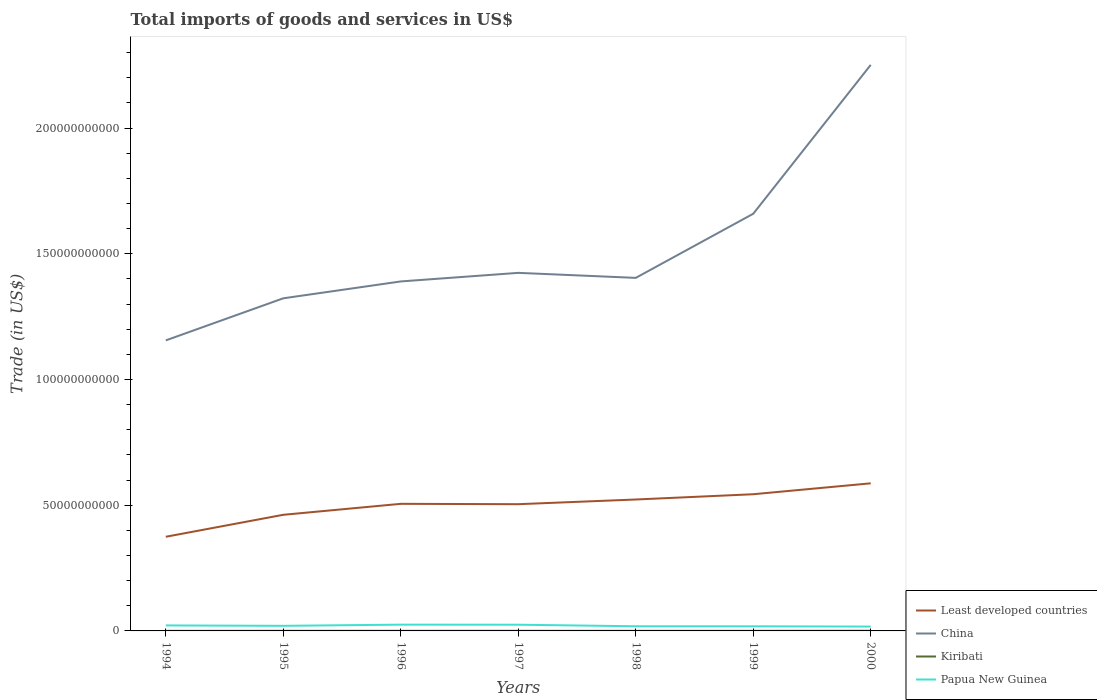How many different coloured lines are there?
Keep it short and to the point. 4. Does the line corresponding to Least developed countries intersect with the line corresponding to China?
Your answer should be very brief. No. Across all years, what is the maximum total imports of goods and services in Least developed countries?
Your answer should be compact. 3.75e+1. In which year was the total imports of goods and services in Kiribati maximum?
Offer a terse response. 1994. What is the total total imports of goods and services in Least developed countries in the graph?
Your answer should be compact. -4.22e+09. What is the difference between the highest and the second highest total imports of goods and services in Papua New Guinea?
Your response must be concise. 7.61e+08. Are the values on the major ticks of Y-axis written in scientific E-notation?
Make the answer very short. No. Does the graph contain any zero values?
Offer a very short reply. No. Does the graph contain grids?
Offer a terse response. No. Where does the legend appear in the graph?
Give a very brief answer. Bottom right. How many legend labels are there?
Offer a very short reply. 4. How are the legend labels stacked?
Provide a short and direct response. Vertical. What is the title of the graph?
Give a very brief answer. Total imports of goods and services in US$. What is the label or title of the X-axis?
Make the answer very short. Years. What is the label or title of the Y-axis?
Your response must be concise. Trade (in US$). What is the Trade (in US$) of Least developed countries in 1994?
Your answer should be compact. 3.75e+1. What is the Trade (in US$) of China in 1994?
Provide a succinct answer. 1.16e+11. What is the Trade (in US$) in Kiribati in 1994?
Provide a succinct answer. 3.38e+07. What is the Trade (in US$) of Papua New Guinea in 1994?
Ensure brevity in your answer.  2.19e+09. What is the Trade (in US$) in Least developed countries in 1995?
Provide a succinct answer. 4.62e+1. What is the Trade (in US$) of China in 1995?
Your answer should be very brief. 1.32e+11. What is the Trade (in US$) of Kiribati in 1995?
Your answer should be compact. 4.14e+07. What is the Trade (in US$) in Papua New Guinea in 1995?
Offer a very short reply. 2.03e+09. What is the Trade (in US$) of Least developed countries in 1996?
Provide a succinct answer. 5.06e+1. What is the Trade (in US$) in China in 1996?
Offer a very short reply. 1.39e+11. What is the Trade (in US$) in Kiribati in 1996?
Keep it short and to the point. 4.62e+07. What is the Trade (in US$) of Papua New Guinea in 1996?
Keep it short and to the point. 2.50e+09. What is the Trade (in US$) in Least developed countries in 1997?
Your response must be concise. 5.04e+1. What is the Trade (in US$) of China in 1997?
Offer a very short reply. 1.42e+11. What is the Trade (in US$) in Kiribati in 1997?
Make the answer very short. 4.29e+07. What is the Trade (in US$) of Papua New Guinea in 1997?
Your answer should be very brief. 2.47e+09. What is the Trade (in US$) in Least developed countries in 1998?
Make the answer very short. 5.23e+1. What is the Trade (in US$) in China in 1998?
Offer a very short reply. 1.40e+11. What is the Trade (in US$) in Kiribati in 1998?
Give a very brief answer. 3.48e+07. What is the Trade (in US$) of Papua New Guinea in 1998?
Make the answer very short. 1.85e+09. What is the Trade (in US$) in Least developed countries in 1999?
Provide a short and direct response. 5.44e+1. What is the Trade (in US$) in China in 1999?
Offer a very short reply. 1.66e+11. What is the Trade (in US$) in Kiribati in 1999?
Keep it short and to the point. 3.72e+07. What is the Trade (in US$) in Papua New Guinea in 1999?
Your answer should be very brief. 1.84e+09. What is the Trade (in US$) in Least developed countries in 2000?
Your answer should be compact. 5.87e+1. What is the Trade (in US$) in China in 2000?
Your answer should be compact. 2.25e+11. What is the Trade (in US$) of Kiribati in 2000?
Your answer should be compact. 6.25e+07. What is the Trade (in US$) in Papua New Guinea in 2000?
Keep it short and to the point. 1.73e+09. Across all years, what is the maximum Trade (in US$) of Least developed countries?
Give a very brief answer. 5.87e+1. Across all years, what is the maximum Trade (in US$) in China?
Offer a terse response. 2.25e+11. Across all years, what is the maximum Trade (in US$) in Kiribati?
Make the answer very short. 6.25e+07. Across all years, what is the maximum Trade (in US$) of Papua New Guinea?
Offer a terse response. 2.50e+09. Across all years, what is the minimum Trade (in US$) in Least developed countries?
Offer a very short reply. 3.75e+1. Across all years, what is the minimum Trade (in US$) of China?
Keep it short and to the point. 1.16e+11. Across all years, what is the minimum Trade (in US$) of Kiribati?
Your response must be concise. 3.38e+07. Across all years, what is the minimum Trade (in US$) of Papua New Guinea?
Offer a terse response. 1.73e+09. What is the total Trade (in US$) in Least developed countries in the graph?
Make the answer very short. 3.50e+11. What is the total Trade (in US$) of China in the graph?
Your answer should be very brief. 1.06e+12. What is the total Trade (in US$) in Kiribati in the graph?
Offer a terse response. 2.99e+08. What is the total Trade (in US$) in Papua New Guinea in the graph?
Provide a short and direct response. 1.46e+1. What is the difference between the Trade (in US$) of Least developed countries in 1994 and that in 1995?
Keep it short and to the point. -8.74e+09. What is the difference between the Trade (in US$) of China in 1994 and that in 1995?
Offer a very short reply. -1.67e+1. What is the difference between the Trade (in US$) of Kiribati in 1994 and that in 1995?
Provide a succinct answer. -7.69e+06. What is the difference between the Trade (in US$) of Papua New Guinea in 1994 and that in 1995?
Make the answer very short. 1.62e+08. What is the difference between the Trade (in US$) in Least developed countries in 1994 and that in 1996?
Give a very brief answer. -1.31e+1. What is the difference between the Trade (in US$) of China in 1994 and that in 1996?
Ensure brevity in your answer.  -2.34e+1. What is the difference between the Trade (in US$) in Kiribati in 1994 and that in 1996?
Your answer should be compact. -1.25e+07. What is the difference between the Trade (in US$) in Papua New Guinea in 1994 and that in 1996?
Offer a very short reply. -3.07e+08. What is the difference between the Trade (in US$) in Least developed countries in 1994 and that in 1997?
Ensure brevity in your answer.  -1.30e+1. What is the difference between the Trade (in US$) of China in 1994 and that in 1997?
Give a very brief answer. -2.69e+1. What is the difference between the Trade (in US$) of Kiribati in 1994 and that in 1997?
Your response must be concise. -9.14e+06. What is the difference between the Trade (in US$) in Papua New Guinea in 1994 and that in 1997?
Provide a succinct answer. -2.82e+08. What is the difference between the Trade (in US$) of Least developed countries in 1994 and that in 1998?
Keep it short and to the point. -1.48e+1. What is the difference between the Trade (in US$) in China in 1994 and that in 1998?
Provide a short and direct response. -2.49e+1. What is the difference between the Trade (in US$) of Kiribati in 1994 and that in 1998?
Provide a succinct answer. -9.97e+05. What is the difference between the Trade (in US$) in Papua New Guinea in 1994 and that in 1998?
Your answer should be very brief. 3.38e+08. What is the difference between the Trade (in US$) of Least developed countries in 1994 and that in 1999?
Ensure brevity in your answer.  -1.69e+1. What is the difference between the Trade (in US$) in China in 1994 and that in 1999?
Ensure brevity in your answer.  -5.04e+1. What is the difference between the Trade (in US$) of Kiribati in 1994 and that in 1999?
Ensure brevity in your answer.  -3.41e+06. What is the difference between the Trade (in US$) of Papua New Guinea in 1994 and that in 1999?
Keep it short and to the point. 3.49e+08. What is the difference between the Trade (in US$) of Least developed countries in 1994 and that in 2000?
Your answer should be very brief. -2.13e+1. What is the difference between the Trade (in US$) in China in 1994 and that in 2000?
Provide a succinct answer. -1.10e+11. What is the difference between the Trade (in US$) of Kiribati in 1994 and that in 2000?
Give a very brief answer. -2.87e+07. What is the difference between the Trade (in US$) in Papua New Guinea in 1994 and that in 2000?
Offer a very short reply. 4.54e+08. What is the difference between the Trade (in US$) of Least developed countries in 1995 and that in 1996?
Ensure brevity in your answer.  -4.36e+09. What is the difference between the Trade (in US$) of China in 1995 and that in 1996?
Your answer should be very brief. -6.71e+09. What is the difference between the Trade (in US$) in Kiribati in 1995 and that in 1996?
Keep it short and to the point. -4.80e+06. What is the difference between the Trade (in US$) in Papua New Guinea in 1995 and that in 1996?
Your answer should be compact. -4.69e+08. What is the difference between the Trade (in US$) of Least developed countries in 1995 and that in 1997?
Your response must be concise. -4.22e+09. What is the difference between the Trade (in US$) in China in 1995 and that in 1997?
Your answer should be compact. -1.01e+1. What is the difference between the Trade (in US$) of Kiribati in 1995 and that in 1997?
Make the answer very short. -1.45e+06. What is the difference between the Trade (in US$) in Papua New Guinea in 1995 and that in 1997?
Provide a succinct answer. -4.45e+08. What is the difference between the Trade (in US$) in Least developed countries in 1995 and that in 1998?
Offer a terse response. -6.08e+09. What is the difference between the Trade (in US$) of China in 1995 and that in 1998?
Keep it short and to the point. -8.13e+09. What is the difference between the Trade (in US$) of Kiribati in 1995 and that in 1998?
Offer a very short reply. 6.69e+06. What is the difference between the Trade (in US$) of Papua New Guinea in 1995 and that in 1998?
Offer a very short reply. 1.76e+08. What is the difference between the Trade (in US$) in Least developed countries in 1995 and that in 1999?
Give a very brief answer. -8.18e+09. What is the difference between the Trade (in US$) in China in 1995 and that in 1999?
Make the answer very short. -3.36e+1. What is the difference between the Trade (in US$) of Kiribati in 1995 and that in 1999?
Provide a succinct answer. 4.28e+06. What is the difference between the Trade (in US$) of Papua New Guinea in 1995 and that in 1999?
Ensure brevity in your answer.  1.87e+08. What is the difference between the Trade (in US$) in Least developed countries in 1995 and that in 2000?
Offer a very short reply. -1.25e+1. What is the difference between the Trade (in US$) in China in 1995 and that in 2000?
Give a very brief answer. -9.28e+1. What is the difference between the Trade (in US$) in Kiribati in 1995 and that in 2000?
Provide a short and direct response. -2.10e+07. What is the difference between the Trade (in US$) of Papua New Guinea in 1995 and that in 2000?
Keep it short and to the point. 2.92e+08. What is the difference between the Trade (in US$) in Least developed countries in 1996 and that in 1997?
Provide a short and direct response. 1.39e+08. What is the difference between the Trade (in US$) in China in 1996 and that in 1997?
Offer a very short reply. -3.41e+09. What is the difference between the Trade (in US$) in Kiribati in 1996 and that in 1997?
Your answer should be compact. 3.35e+06. What is the difference between the Trade (in US$) of Papua New Guinea in 1996 and that in 1997?
Make the answer very short. 2.44e+07. What is the difference between the Trade (in US$) of Least developed countries in 1996 and that in 1998?
Your answer should be compact. -1.72e+09. What is the difference between the Trade (in US$) in China in 1996 and that in 1998?
Provide a succinct answer. -1.42e+09. What is the difference between the Trade (in US$) of Kiribati in 1996 and that in 1998?
Ensure brevity in your answer.  1.15e+07. What is the difference between the Trade (in US$) in Papua New Guinea in 1996 and that in 1998?
Offer a very short reply. 6.45e+08. What is the difference between the Trade (in US$) of Least developed countries in 1996 and that in 1999?
Offer a terse response. -3.82e+09. What is the difference between the Trade (in US$) in China in 1996 and that in 1999?
Make the answer very short. -2.69e+1. What is the difference between the Trade (in US$) in Kiribati in 1996 and that in 1999?
Offer a very short reply. 9.09e+06. What is the difference between the Trade (in US$) in Papua New Guinea in 1996 and that in 1999?
Your answer should be very brief. 6.56e+08. What is the difference between the Trade (in US$) of Least developed countries in 1996 and that in 2000?
Your response must be concise. -8.16e+09. What is the difference between the Trade (in US$) of China in 1996 and that in 2000?
Provide a succinct answer. -8.61e+1. What is the difference between the Trade (in US$) of Kiribati in 1996 and that in 2000?
Offer a very short reply. -1.62e+07. What is the difference between the Trade (in US$) in Papua New Guinea in 1996 and that in 2000?
Offer a terse response. 7.61e+08. What is the difference between the Trade (in US$) of Least developed countries in 1997 and that in 1998?
Your answer should be very brief. -1.86e+09. What is the difference between the Trade (in US$) in China in 1997 and that in 1998?
Your answer should be compact. 1.99e+09. What is the difference between the Trade (in US$) of Kiribati in 1997 and that in 1998?
Your answer should be compact. 8.14e+06. What is the difference between the Trade (in US$) in Papua New Guinea in 1997 and that in 1998?
Your answer should be compact. 6.21e+08. What is the difference between the Trade (in US$) in Least developed countries in 1997 and that in 1999?
Offer a terse response. -3.96e+09. What is the difference between the Trade (in US$) of China in 1997 and that in 1999?
Ensure brevity in your answer.  -2.35e+1. What is the difference between the Trade (in US$) in Kiribati in 1997 and that in 1999?
Offer a very short reply. 5.74e+06. What is the difference between the Trade (in US$) of Papua New Guinea in 1997 and that in 1999?
Keep it short and to the point. 6.32e+08. What is the difference between the Trade (in US$) of Least developed countries in 1997 and that in 2000?
Your response must be concise. -8.30e+09. What is the difference between the Trade (in US$) of China in 1997 and that in 2000?
Your response must be concise. -8.27e+1. What is the difference between the Trade (in US$) of Kiribati in 1997 and that in 2000?
Keep it short and to the point. -1.96e+07. What is the difference between the Trade (in US$) in Papua New Guinea in 1997 and that in 2000?
Keep it short and to the point. 7.37e+08. What is the difference between the Trade (in US$) in Least developed countries in 1998 and that in 1999?
Your answer should be compact. -2.10e+09. What is the difference between the Trade (in US$) in China in 1998 and that in 1999?
Offer a very short reply. -2.55e+1. What is the difference between the Trade (in US$) of Kiribati in 1998 and that in 1999?
Ensure brevity in your answer.  -2.41e+06. What is the difference between the Trade (in US$) of Papua New Guinea in 1998 and that in 1999?
Make the answer very short. 1.10e+07. What is the difference between the Trade (in US$) of Least developed countries in 1998 and that in 2000?
Ensure brevity in your answer.  -6.44e+09. What is the difference between the Trade (in US$) of China in 1998 and that in 2000?
Your answer should be compact. -8.47e+1. What is the difference between the Trade (in US$) of Kiribati in 1998 and that in 2000?
Provide a succinct answer. -2.77e+07. What is the difference between the Trade (in US$) of Papua New Guinea in 1998 and that in 2000?
Give a very brief answer. 1.16e+08. What is the difference between the Trade (in US$) in Least developed countries in 1999 and that in 2000?
Your answer should be compact. -4.34e+09. What is the difference between the Trade (in US$) of China in 1999 and that in 2000?
Your response must be concise. -5.92e+1. What is the difference between the Trade (in US$) of Kiribati in 1999 and that in 2000?
Give a very brief answer. -2.53e+07. What is the difference between the Trade (in US$) of Papua New Guinea in 1999 and that in 2000?
Your answer should be very brief. 1.05e+08. What is the difference between the Trade (in US$) of Least developed countries in 1994 and the Trade (in US$) of China in 1995?
Your answer should be very brief. -9.49e+1. What is the difference between the Trade (in US$) in Least developed countries in 1994 and the Trade (in US$) in Kiribati in 1995?
Give a very brief answer. 3.74e+1. What is the difference between the Trade (in US$) in Least developed countries in 1994 and the Trade (in US$) in Papua New Guinea in 1995?
Provide a short and direct response. 3.54e+1. What is the difference between the Trade (in US$) of China in 1994 and the Trade (in US$) of Kiribati in 1995?
Keep it short and to the point. 1.16e+11. What is the difference between the Trade (in US$) of China in 1994 and the Trade (in US$) of Papua New Guinea in 1995?
Provide a short and direct response. 1.14e+11. What is the difference between the Trade (in US$) in Kiribati in 1994 and the Trade (in US$) in Papua New Guinea in 1995?
Provide a succinct answer. -1.99e+09. What is the difference between the Trade (in US$) in Least developed countries in 1994 and the Trade (in US$) in China in 1996?
Offer a very short reply. -1.02e+11. What is the difference between the Trade (in US$) of Least developed countries in 1994 and the Trade (in US$) of Kiribati in 1996?
Your response must be concise. 3.74e+1. What is the difference between the Trade (in US$) in Least developed countries in 1994 and the Trade (in US$) in Papua New Guinea in 1996?
Your response must be concise. 3.50e+1. What is the difference between the Trade (in US$) of China in 1994 and the Trade (in US$) of Kiribati in 1996?
Keep it short and to the point. 1.16e+11. What is the difference between the Trade (in US$) of China in 1994 and the Trade (in US$) of Papua New Guinea in 1996?
Your answer should be very brief. 1.13e+11. What is the difference between the Trade (in US$) of Kiribati in 1994 and the Trade (in US$) of Papua New Guinea in 1996?
Your answer should be very brief. -2.46e+09. What is the difference between the Trade (in US$) of Least developed countries in 1994 and the Trade (in US$) of China in 1997?
Offer a very short reply. -1.05e+11. What is the difference between the Trade (in US$) of Least developed countries in 1994 and the Trade (in US$) of Kiribati in 1997?
Give a very brief answer. 3.74e+1. What is the difference between the Trade (in US$) of Least developed countries in 1994 and the Trade (in US$) of Papua New Guinea in 1997?
Give a very brief answer. 3.50e+1. What is the difference between the Trade (in US$) in China in 1994 and the Trade (in US$) in Kiribati in 1997?
Provide a short and direct response. 1.16e+11. What is the difference between the Trade (in US$) of China in 1994 and the Trade (in US$) of Papua New Guinea in 1997?
Offer a very short reply. 1.13e+11. What is the difference between the Trade (in US$) in Kiribati in 1994 and the Trade (in US$) in Papua New Guinea in 1997?
Provide a succinct answer. -2.44e+09. What is the difference between the Trade (in US$) of Least developed countries in 1994 and the Trade (in US$) of China in 1998?
Give a very brief answer. -1.03e+11. What is the difference between the Trade (in US$) in Least developed countries in 1994 and the Trade (in US$) in Kiribati in 1998?
Offer a terse response. 3.74e+1. What is the difference between the Trade (in US$) in Least developed countries in 1994 and the Trade (in US$) in Papua New Guinea in 1998?
Give a very brief answer. 3.56e+1. What is the difference between the Trade (in US$) of China in 1994 and the Trade (in US$) of Kiribati in 1998?
Keep it short and to the point. 1.16e+11. What is the difference between the Trade (in US$) of China in 1994 and the Trade (in US$) of Papua New Guinea in 1998?
Offer a very short reply. 1.14e+11. What is the difference between the Trade (in US$) in Kiribati in 1994 and the Trade (in US$) in Papua New Guinea in 1998?
Your answer should be compact. -1.82e+09. What is the difference between the Trade (in US$) in Least developed countries in 1994 and the Trade (in US$) in China in 1999?
Offer a very short reply. -1.28e+11. What is the difference between the Trade (in US$) of Least developed countries in 1994 and the Trade (in US$) of Kiribati in 1999?
Offer a terse response. 3.74e+1. What is the difference between the Trade (in US$) in Least developed countries in 1994 and the Trade (in US$) in Papua New Guinea in 1999?
Offer a terse response. 3.56e+1. What is the difference between the Trade (in US$) of China in 1994 and the Trade (in US$) of Kiribati in 1999?
Make the answer very short. 1.16e+11. What is the difference between the Trade (in US$) in China in 1994 and the Trade (in US$) in Papua New Guinea in 1999?
Make the answer very short. 1.14e+11. What is the difference between the Trade (in US$) of Kiribati in 1994 and the Trade (in US$) of Papua New Guinea in 1999?
Ensure brevity in your answer.  -1.81e+09. What is the difference between the Trade (in US$) of Least developed countries in 1994 and the Trade (in US$) of China in 2000?
Offer a terse response. -1.88e+11. What is the difference between the Trade (in US$) in Least developed countries in 1994 and the Trade (in US$) in Kiribati in 2000?
Make the answer very short. 3.74e+1. What is the difference between the Trade (in US$) in Least developed countries in 1994 and the Trade (in US$) in Papua New Guinea in 2000?
Offer a terse response. 3.57e+1. What is the difference between the Trade (in US$) in China in 1994 and the Trade (in US$) in Kiribati in 2000?
Give a very brief answer. 1.16e+11. What is the difference between the Trade (in US$) in China in 1994 and the Trade (in US$) in Papua New Guinea in 2000?
Make the answer very short. 1.14e+11. What is the difference between the Trade (in US$) in Kiribati in 1994 and the Trade (in US$) in Papua New Guinea in 2000?
Your answer should be very brief. -1.70e+09. What is the difference between the Trade (in US$) in Least developed countries in 1995 and the Trade (in US$) in China in 1996?
Your answer should be very brief. -9.28e+1. What is the difference between the Trade (in US$) of Least developed countries in 1995 and the Trade (in US$) of Kiribati in 1996?
Provide a short and direct response. 4.61e+1. What is the difference between the Trade (in US$) of Least developed countries in 1995 and the Trade (in US$) of Papua New Guinea in 1996?
Your response must be concise. 4.37e+1. What is the difference between the Trade (in US$) in China in 1995 and the Trade (in US$) in Kiribati in 1996?
Provide a short and direct response. 1.32e+11. What is the difference between the Trade (in US$) in China in 1995 and the Trade (in US$) in Papua New Guinea in 1996?
Keep it short and to the point. 1.30e+11. What is the difference between the Trade (in US$) of Kiribati in 1995 and the Trade (in US$) of Papua New Guinea in 1996?
Make the answer very short. -2.45e+09. What is the difference between the Trade (in US$) of Least developed countries in 1995 and the Trade (in US$) of China in 1997?
Make the answer very short. -9.62e+1. What is the difference between the Trade (in US$) in Least developed countries in 1995 and the Trade (in US$) in Kiribati in 1997?
Provide a succinct answer. 4.61e+1. What is the difference between the Trade (in US$) of Least developed countries in 1995 and the Trade (in US$) of Papua New Guinea in 1997?
Offer a terse response. 4.37e+1. What is the difference between the Trade (in US$) in China in 1995 and the Trade (in US$) in Kiribati in 1997?
Make the answer very short. 1.32e+11. What is the difference between the Trade (in US$) in China in 1995 and the Trade (in US$) in Papua New Guinea in 1997?
Provide a short and direct response. 1.30e+11. What is the difference between the Trade (in US$) in Kiribati in 1995 and the Trade (in US$) in Papua New Guinea in 1997?
Ensure brevity in your answer.  -2.43e+09. What is the difference between the Trade (in US$) in Least developed countries in 1995 and the Trade (in US$) in China in 1998?
Keep it short and to the point. -9.42e+1. What is the difference between the Trade (in US$) of Least developed countries in 1995 and the Trade (in US$) of Kiribati in 1998?
Offer a very short reply. 4.62e+1. What is the difference between the Trade (in US$) in Least developed countries in 1995 and the Trade (in US$) in Papua New Guinea in 1998?
Provide a succinct answer. 4.43e+1. What is the difference between the Trade (in US$) of China in 1995 and the Trade (in US$) of Kiribati in 1998?
Give a very brief answer. 1.32e+11. What is the difference between the Trade (in US$) in China in 1995 and the Trade (in US$) in Papua New Guinea in 1998?
Your response must be concise. 1.30e+11. What is the difference between the Trade (in US$) of Kiribati in 1995 and the Trade (in US$) of Papua New Guinea in 1998?
Your answer should be very brief. -1.81e+09. What is the difference between the Trade (in US$) in Least developed countries in 1995 and the Trade (in US$) in China in 1999?
Offer a terse response. -1.20e+11. What is the difference between the Trade (in US$) in Least developed countries in 1995 and the Trade (in US$) in Kiribati in 1999?
Keep it short and to the point. 4.62e+1. What is the difference between the Trade (in US$) in Least developed countries in 1995 and the Trade (in US$) in Papua New Guinea in 1999?
Your answer should be compact. 4.43e+1. What is the difference between the Trade (in US$) in China in 1995 and the Trade (in US$) in Kiribati in 1999?
Provide a succinct answer. 1.32e+11. What is the difference between the Trade (in US$) of China in 1995 and the Trade (in US$) of Papua New Guinea in 1999?
Provide a succinct answer. 1.30e+11. What is the difference between the Trade (in US$) of Kiribati in 1995 and the Trade (in US$) of Papua New Guinea in 1999?
Your answer should be compact. -1.80e+09. What is the difference between the Trade (in US$) in Least developed countries in 1995 and the Trade (in US$) in China in 2000?
Provide a short and direct response. -1.79e+11. What is the difference between the Trade (in US$) of Least developed countries in 1995 and the Trade (in US$) of Kiribati in 2000?
Offer a terse response. 4.61e+1. What is the difference between the Trade (in US$) in Least developed countries in 1995 and the Trade (in US$) in Papua New Guinea in 2000?
Make the answer very short. 4.45e+1. What is the difference between the Trade (in US$) in China in 1995 and the Trade (in US$) in Kiribati in 2000?
Ensure brevity in your answer.  1.32e+11. What is the difference between the Trade (in US$) in China in 1995 and the Trade (in US$) in Papua New Guinea in 2000?
Your answer should be compact. 1.31e+11. What is the difference between the Trade (in US$) in Kiribati in 1995 and the Trade (in US$) in Papua New Guinea in 2000?
Offer a very short reply. -1.69e+09. What is the difference between the Trade (in US$) in Least developed countries in 1996 and the Trade (in US$) in China in 1997?
Your response must be concise. -9.19e+1. What is the difference between the Trade (in US$) of Least developed countries in 1996 and the Trade (in US$) of Kiribati in 1997?
Give a very brief answer. 5.05e+1. What is the difference between the Trade (in US$) of Least developed countries in 1996 and the Trade (in US$) of Papua New Guinea in 1997?
Your response must be concise. 4.81e+1. What is the difference between the Trade (in US$) in China in 1996 and the Trade (in US$) in Kiribati in 1997?
Ensure brevity in your answer.  1.39e+11. What is the difference between the Trade (in US$) of China in 1996 and the Trade (in US$) of Papua New Guinea in 1997?
Provide a short and direct response. 1.37e+11. What is the difference between the Trade (in US$) of Kiribati in 1996 and the Trade (in US$) of Papua New Guinea in 1997?
Keep it short and to the point. -2.42e+09. What is the difference between the Trade (in US$) of Least developed countries in 1996 and the Trade (in US$) of China in 1998?
Your answer should be very brief. -8.99e+1. What is the difference between the Trade (in US$) of Least developed countries in 1996 and the Trade (in US$) of Kiribati in 1998?
Your response must be concise. 5.05e+1. What is the difference between the Trade (in US$) in Least developed countries in 1996 and the Trade (in US$) in Papua New Guinea in 1998?
Keep it short and to the point. 4.87e+1. What is the difference between the Trade (in US$) of China in 1996 and the Trade (in US$) of Kiribati in 1998?
Offer a terse response. 1.39e+11. What is the difference between the Trade (in US$) in China in 1996 and the Trade (in US$) in Papua New Guinea in 1998?
Offer a terse response. 1.37e+11. What is the difference between the Trade (in US$) of Kiribati in 1996 and the Trade (in US$) of Papua New Guinea in 1998?
Ensure brevity in your answer.  -1.80e+09. What is the difference between the Trade (in US$) of Least developed countries in 1996 and the Trade (in US$) of China in 1999?
Ensure brevity in your answer.  -1.15e+11. What is the difference between the Trade (in US$) in Least developed countries in 1996 and the Trade (in US$) in Kiribati in 1999?
Provide a short and direct response. 5.05e+1. What is the difference between the Trade (in US$) of Least developed countries in 1996 and the Trade (in US$) of Papua New Guinea in 1999?
Offer a terse response. 4.87e+1. What is the difference between the Trade (in US$) of China in 1996 and the Trade (in US$) of Kiribati in 1999?
Make the answer very short. 1.39e+11. What is the difference between the Trade (in US$) of China in 1996 and the Trade (in US$) of Papua New Guinea in 1999?
Offer a very short reply. 1.37e+11. What is the difference between the Trade (in US$) in Kiribati in 1996 and the Trade (in US$) in Papua New Guinea in 1999?
Give a very brief answer. -1.79e+09. What is the difference between the Trade (in US$) in Least developed countries in 1996 and the Trade (in US$) in China in 2000?
Ensure brevity in your answer.  -1.75e+11. What is the difference between the Trade (in US$) in Least developed countries in 1996 and the Trade (in US$) in Kiribati in 2000?
Provide a succinct answer. 5.05e+1. What is the difference between the Trade (in US$) of Least developed countries in 1996 and the Trade (in US$) of Papua New Guinea in 2000?
Provide a short and direct response. 4.88e+1. What is the difference between the Trade (in US$) of China in 1996 and the Trade (in US$) of Kiribati in 2000?
Offer a terse response. 1.39e+11. What is the difference between the Trade (in US$) of China in 1996 and the Trade (in US$) of Papua New Guinea in 2000?
Offer a terse response. 1.37e+11. What is the difference between the Trade (in US$) in Kiribati in 1996 and the Trade (in US$) in Papua New Guinea in 2000?
Your answer should be very brief. -1.69e+09. What is the difference between the Trade (in US$) in Least developed countries in 1997 and the Trade (in US$) in China in 1998?
Ensure brevity in your answer.  -9.00e+1. What is the difference between the Trade (in US$) of Least developed countries in 1997 and the Trade (in US$) of Kiribati in 1998?
Provide a short and direct response. 5.04e+1. What is the difference between the Trade (in US$) in Least developed countries in 1997 and the Trade (in US$) in Papua New Guinea in 1998?
Keep it short and to the point. 4.86e+1. What is the difference between the Trade (in US$) of China in 1997 and the Trade (in US$) of Kiribati in 1998?
Offer a very short reply. 1.42e+11. What is the difference between the Trade (in US$) of China in 1997 and the Trade (in US$) of Papua New Guinea in 1998?
Keep it short and to the point. 1.41e+11. What is the difference between the Trade (in US$) in Kiribati in 1997 and the Trade (in US$) in Papua New Guinea in 1998?
Your answer should be very brief. -1.81e+09. What is the difference between the Trade (in US$) of Least developed countries in 1997 and the Trade (in US$) of China in 1999?
Give a very brief answer. -1.16e+11. What is the difference between the Trade (in US$) of Least developed countries in 1997 and the Trade (in US$) of Kiribati in 1999?
Offer a very short reply. 5.04e+1. What is the difference between the Trade (in US$) in Least developed countries in 1997 and the Trade (in US$) in Papua New Guinea in 1999?
Offer a very short reply. 4.86e+1. What is the difference between the Trade (in US$) of China in 1997 and the Trade (in US$) of Kiribati in 1999?
Your answer should be compact. 1.42e+11. What is the difference between the Trade (in US$) of China in 1997 and the Trade (in US$) of Papua New Guinea in 1999?
Your answer should be very brief. 1.41e+11. What is the difference between the Trade (in US$) of Kiribati in 1997 and the Trade (in US$) of Papua New Guinea in 1999?
Your answer should be very brief. -1.80e+09. What is the difference between the Trade (in US$) in Least developed countries in 1997 and the Trade (in US$) in China in 2000?
Keep it short and to the point. -1.75e+11. What is the difference between the Trade (in US$) in Least developed countries in 1997 and the Trade (in US$) in Kiribati in 2000?
Give a very brief answer. 5.03e+1. What is the difference between the Trade (in US$) of Least developed countries in 1997 and the Trade (in US$) of Papua New Guinea in 2000?
Provide a succinct answer. 4.87e+1. What is the difference between the Trade (in US$) in China in 1997 and the Trade (in US$) in Kiribati in 2000?
Your answer should be compact. 1.42e+11. What is the difference between the Trade (in US$) of China in 1997 and the Trade (in US$) of Papua New Guinea in 2000?
Ensure brevity in your answer.  1.41e+11. What is the difference between the Trade (in US$) in Kiribati in 1997 and the Trade (in US$) in Papua New Guinea in 2000?
Keep it short and to the point. -1.69e+09. What is the difference between the Trade (in US$) of Least developed countries in 1998 and the Trade (in US$) of China in 1999?
Keep it short and to the point. -1.14e+11. What is the difference between the Trade (in US$) in Least developed countries in 1998 and the Trade (in US$) in Kiribati in 1999?
Ensure brevity in your answer.  5.22e+1. What is the difference between the Trade (in US$) of Least developed countries in 1998 and the Trade (in US$) of Papua New Guinea in 1999?
Keep it short and to the point. 5.04e+1. What is the difference between the Trade (in US$) of China in 1998 and the Trade (in US$) of Kiribati in 1999?
Your answer should be compact. 1.40e+11. What is the difference between the Trade (in US$) in China in 1998 and the Trade (in US$) in Papua New Guinea in 1999?
Offer a terse response. 1.39e+11. What is the difference between the Trade (in US$) of Kiribati in 1998 and the Trade (in US$) of Papua New Guinea in 1999?
Your response must be concise. -1.80e+09. What is the difference between the Trade (in US$) in Least developed countries in 1998 and the Trade (in US$) in China in 2000?
Give a very brief answer. -1.73e+11. What is the difference between the Trade (in US$) of Least developed countries in 1998 and the Trade (in US$) of Kiribati in 2000?
Your response must be concise. 5.22e+1. What is the difference between the Trade (in US$) in Least developed countries in 1998 and the Trade (in US$) in Papua New Guinea in 2000?
Your answer should be compact. 5.05e+1. What is the difference between the Trade (in US$) in China in 1998 and the Trade (in US$) in Kiribati in 2000?
Ensure brevity in your answer.  1.40e+11. What is the difference between the Trade (in US$) of China in 1998 and the Trade (in US$) of Papua New Guinea in 2000?
Provide a succinct answer. 1.39e+11. What is the difference between the Trade (in US$) in Kiribati in 1998 and the Trade (in US$) in Papua New Guinea in 2000?
Keep it short and to the point. -1.70e+09. What is the difference between the Trade (in US$) in Least developed countries in 1999 and the Trade (in US$) in China in 2000?
Offer a terse response. -1.71e+11. What is the difference between the Trade (in US$) in Least developed countries in 1999 and the Trade (in US$) in Kiribati in 2000?
Provide a succinct answer. 5.43e+1. What is the difference between the Trade (in US$) of Least developed countries in 1999 and the Trade (in US$) of Papua New Guinea in 2000?
Keep it short and to the point. 5.26e+1. What is the difference between the Trade (in US$) of China in 1999 and the Trade (in US$) of Kiribati in 2000?
Provide a short and direct response. 1.66e+11. What is the difference between the Trade (in US$) of China in 1999 and the Trade (in US$) of Papua New Guinea in 2000?
Your answer should be compact. 1.64e+11. What is the difference between the Trade (in US$) in Kiribati in 1999 and the Trade (in US$) in Papua New Guinea in 2000?
Offer a very short reply. -1.70e+09. What is the average Trade (in US$) of Least developed countries per year?
Your response must be concise. 5.00e+1. What is the average Trade (in US$) in China per year?
Keep it short and to the point. 1.52e+11. What is the average Trade (in US$) in Kiribati per year?
Ensure brevity in your answer.  4.27e+07. What is the average Trade (in US$) in Papua New Guinea per year?
Provide a succinct answer. 2.09e+09. In the year 1994, what is the difference between the Trade (in US$) in Least developed countries and Trade (in US$) in China?
Give a very brief answer. -7.81e+1. In the year 1994, what is the difference between the Trade (in US$) in Least developed countries and Trade (in US$) in Kiribati?
Keep it short and to the point. 3.74e+1. In the year 1994, what is the difference between the Trade (in US$) of Least developed countries and Trade (in US$) of Papua New Guinea?
Provide a succinct answer. 3.53e+1. In the year 1994, what is the difference between the Trade (in US$) of China and Trade (in US$) of Kiribati?
Make the answer very short. 1.16e+11. In the year 1994, what is the difference between the Trade (in US$) in China and Trade (in US$) in Papua New Guinea?
Provide a succinct answer. 1.13e+11. In the year 1994, what is the difference between the Trade (in US$) in Kiribati and Trade (in US$) in Papua New Guinea?
Provide a succinct answer. -2.15e+09. In the year 1995, what is the difference between the Trade (in US$) in Least developed countries and Trade (in US$) in China?
Ensure brevity in your answer.  -8.61e+1. In the year 1995, what is the difference between the Trade (in US$) of Least developed countries and Trade (in US$) of Kiribati?
Keep it short and to the point. 4.61e+1. In the year 1995, what is the difference between the Trade (in US$) of Least developed countries and Trade (in US$) of Papua New Guinea?
Offer a very short reply. 4.42e+1. In the year 1995, what is the difference between the Trade (in US$) in China and Trade (in US$) in Kiribati?
Provide a succinct answer. 1.32e+11. In the year 1995, what is the difference between the Trade (in US$) in China and Trade (in US$) in Papua New Guinea?
Offer a very short reply. 1.30e+11. In the year 1995, what is the difference between the Trade (in US$) of Kiribati and Trade (in US$) of Papua New Guinea?
Keep it short and to the point. -1.98e+09. In the year 1996, what is the difference between the Trade (in US$) of Least developed countries and Trade (in US$) of China?
Give a very brief answer. -8.85e+1. In the year 1996, what is the difference between the Trade (in US$) in Least developed countries and Trade (in US$) in Kiribati?
Keep it short and to the point. 5.05e+1. In the year 1996, what is the difference between the Trade (in US$) of Least developed countries and Trade (in US$) of Papua New Guinea?
Give a very brief answer. 4.81e+1. In the year 1996, what is the difference between the Trade (in US$) of China and Trade (in US$) of Kiribati?
Keep it short and to the point. 1.39e+11. In the year 1996, what is the difference between the Trade (in US$) in China and Trade (in US$) in Papua New Guinea?
Give a very brief answer. 1.37e+11. In the year 1996, what is the difference between the Trade (in US$) of Kiribati and Trade (in US$) of Papua New Guinea?
Ensure brevity in your answer.  -2.45e+09. In the year 1997, what is the difference between the Trade (in US$) of Least developed countries and Trade (in US$) of China?
Offer a terse response. -9.20e+1. In the year 1997, what is the difference between the Trade (in US$) of Least developed countries and Trade (in US$) of Kiribati?
Give a very brief answer. 5.04e+1. In the year 1997, what is the difference between the Trade (in US$) in Least developed countries and Trade (in US$) in Papua New Guinea?
Offer a very short reply. 4.79e+1. In the year 1997, what is the difference between the Trade (in US$) in China and Trade (in US$) in Kiribati?
Offer a terse response. 1.42e+11. In the year 1997, what is the difference between the Trade (in US$) in China and Trade (in US$) in Papua New Guinea?
Ensure brevity in your answer.  1.40e+11. In the year 1997, what is the difference between the Trade (in US$) of Kiribati and Trade (in US$) of Papua New Guinea?
Ensure brevity in your answer.  -2.43e+09. In the year 1998, what is the difference between the Trade (in US$) in Least developed countries and Trade (in US$) in China?
Give a very brief answer. -8.82e+1. In the year 1998, what is the difference between the Trade (in US$) of Least developed countries and Trade (in US$) of Kiribati?
Offer a terse response. 5.22e+1. In the year 1998, what is the difference between the Trade (in US$) of Least developed countries and Trade (in US$) of Papua New Guinea?
Provide a succinct answer. 5.04e+1. In the year 1998, what is the difference between the Trade (in US$) of China and Trade (in US$) of Kiribati?
Provide a short and direct response. 1.40e+11. In the year 1998, what is the difference between the Trade (in US$) of China and Trade (in US$) of Papua New Guinea?
Give a very brief answer. 1.39e+11. In the year 1998, what is the difference between the Trade (in US$) in Kiribati and Trade (in US$) in Papua New Guinea?
Make the answer very short. -1.82e+09. In the year 1999, what is the difference between the Trade (in US$) in Least developed countries and Trade (in US$) in China?
Offer a terse response. -1.12e+11. In the year 1999, what is the difference between the Trade (in US$) in Least developed countries and Trade (in US$) in Kiribati?
Your answer should be compact. 5.43e+1. In the year 1999, what is the difference between the Trade (in US$) in Least developed countries and Trade (in US$) in Papua New Guinea?
Offer a terse response. 5.25e+1. In the year 1999, what is the difference between the Trade (in US$) in China and Trade (in US$) in Kiribati?
Make the answer very short. 1.66e+11. In the year 1999, what is the difference between the Trade (in US$) of China and Trade (in US$) of Papua New Guinea?
Ensure brevity in your answer.  1.64e+11. In the year 1999, what is the difference between the Trade (in US$) in Kiribati and Trade (in US$) in Papua New Guinea?
Your answer should be very brief. -1.80e+09. In the year 2000, what is the difference between the Trade (in US$) in Least developed countries and Trade (in US$) in China?
Ensure brevity in your answer.  -1.66e+11. In the year 2000, what is the difference between the Trade (in US$) in Least developed countries and Trade (in US$) in Kiribati?
Ensure brevity in your answer.  5.86e+1. In the year 2000, what is the difference between the Trade (in US$) in Least developed countries and Trade (in US$) in Papua New Guinea?
Ensure brevity in your answer.  5.70e+1. In the year 2000, what is the difference between the Trade (in US$) in China and Trade (in US$) in Kiribati?
Give a very brief answer. 2.25e+11. In the year 2000, what is the difference between the Trade (in US$) in China and Trade (in US$) in Papua New Guinea?
Ensure brevity in your answer.  2.23e+11. In the year 2000, what is the difference between the Trade (in US$) of Kiribati and Trade (in US$) of Papua New Guinea?
Your response must be concise. -1.67e+09. What is the ratio of the Trade (in US$) of Least developed countries in 1994 to that in 1995?
Your response must be concise. 0.81. What is the ratio of the Trade (in US$) of China in 1994 to that in 1995?
Offer a very short reply. 0.87. What is the ratio of the Trade (in US$) in Kiribati in 1994 to that in 1995?
Your response must be concise. 0.81. What is the ratio of the Trade (in US$) in Papua New Guinea in 1994 to that in 1995?
Make the answer very short. 1.08. What is the ratio of the Trade (in US$) in Least developed countries in 1994 to that in 1996?
Ensure brevity in your answer.  0.74. What is the ratio of the Trade (in US$) in China in 1994 to that in 1996?
Keep it short and to the point. 0.83. What is the ratio of the Trade (in US$) in Kiribati in 1994 to that in 1996?
Ensure brevity in your answer.  0.73. What is the ratio of the Trade (in US$) in Papua New Guinea in 1994 to that in 1996?
Give a very brief answer. 0.88. What is the ratio of the Trade (in US$) in Least developed countries in 1994 to that in 1997?
Keep it short and to the point. 0.74. What is the ratio of the Trade (in US$) of China in 1994 to that in 1997?
Provide a short and direct response. 0.81. What is the ratio of the Trade (in US$) of Kiribati in 1994 to that in 1997?
Provide a succinct answer. 0.79. What is the ratio of the Trade (in US$) of Papua New Guinea in 1994 to that in 1997?
Ensure brevity in your answer.  0.89. What is the ratio of the Trade (in US$) in Least developed countries in 1994 to that in 1998?
Keep it short and to the point. 0.72. What is the ratio of the Trade (in US$) of China in 1994 to that in 1998?
Give a very brief answer. 0.82. What is the ratio of the Trade (in US$) in Kiribati in 1994 to that in 1998?
Make the answer very short. 0.97. What is the ratio of the Trade (in US$) of Papua New Guinea in 1994 to that in 1998?
Keep it short and to the point. 1.18. What is the ratio of the Trade (in US$) of Least developed countries in 1994 to that in 1999?
Ensure brevity in your answer.  0.69. What is the ratio of the Trade (in US$) of China in 1994 to that in 1999?
Ensure brevity in your answer.  0.7. What is the ratio of the Trade (in US$) in Kiribati in 1994 to that in 1999?
Ensure brevity in your answer.  0.91. What is the ratio of the Trade (in US$) of Papua New Guinea in 1994 to that in 1999?
Offer a terse response. 1.19. What is the ratio of the Trade (in US$) of Least developed countries in 1994 to that in 2000?
Ensure brevity in your answer.  0.64. What is the ratio of the Trade (in US$) in China in 1994 to that in 2000?
Provide a short and direct response. 0.51. What is the ratio of the Trade (in US$) in Kiribati in 1994 to that in 2000?
Give a very brief answer. 0.54. What is the ratio of the Trade (in US$) in Papua New Guinea in 1994 to that in 2000?
Ensure brevity in your answer.  1.26. What is the ratio of the Trade (in US$) of Least developed countries in 1995 to that in 1996?
Provide a succinct answer. 0.91. What is the ratio of the Trade (in US$) of China in 1995 to that in 1996?
Make the answer very short. 0.95. What is the ratio of the Trade (in US$) in Kiribati in 1995 to that in 1996?
Ensure brevity in your answer.  0.9. What is the ratio of the Trade (in US$) of Papua New Guinea in 1995 to that in 1996?
Give a very brief answer. 0.81. What is the ratio of the Trade (in US$) of Least developed countries in 1995 to that in 1997?
Make the answer very short. 0.92. What is the ratio of the Trade (in US$) in China in 1995 to that in 1997?
Ensure brevity in your answer.  0.93. What is the ratio of the Trade (in US$) in Kiribati in 1995 to that in 1997?
Your response must be concise. 0.97. What is the ratio of the Trade (in US$) in Papua New Guinea in 1995 to that in 1997?
Your answer should be very brief. 0.82. What is the ratio of the Trade (in US$) in Least developed countries in 1995 to that in 1998?
Ensure brevity in your answer.  0.88. What is the ratio of the Trade (in US$) of China in 1995 to that in 1998?
Give a very brief answer. 0.94. What is the ratio of the Trade (in US$) in Kiribati in 1995 to that in 1998?
Offer a very short reply. 1.19. What is the ratio of the Trade (in US$) in Papua New Guinea in 1995 to that in 1998?
Provide a succinct answer. 1.1. What is the ratio of the Trade (in US$) of Least developed countries in 1995 to that in 1999?
Make the answer very short. 0.85. What is the ratio of the Trade (in US$) in China in 1995 to that in 1999?
Offer a terse response. 0.8. What is the ratio of the Trade (in US$) in Kiribati in 1995 to that in 1999?
Your answer should be very brief. 1.12. What is the ratio of the Trade (in US$) of Papua New Guinea in 1995 to that in 1999?
Provide a short and direct response. 1.1. What is the ratio of the Trade (in US$) of Least developed countries in 1995 to that in 2000?
Provide a succinct answer. 0.79. What is the ratio of the Trade (in US$) in China in 1995 to that in 2000?
Offer a terse response. 0.59. What is the ratio of the Trade (in US$) in Kiribati in 1995 to that in 2000?
Provide a succinct answer. 0.66. What is the ratio of the Trade (in US$) in Papua New Guinea in 1995 to that in 2000?
Offer a very short reply. 1.17. What is the ratio of the Trade (in US$) in China in 1996 to that in 1997?
Offer a very short reply. 0.98. What is the ratio of the Trade (in US$) in Kiribati in 1996 to that in 1997?
Your response must be concise. 1.08. What is the ratio of the Trade (in US$) in Papua New Guinea in 1996 to that in 1997?
Provide a succinct answer. 1.01. What is the ratio of the Trade (in US$) in Least developed countries in 1996 to that in 1998?
Keep it short and to the point. 0.97. What is the ratio of the Trade (in US$) in China in 1996 to that in 1998?
Your response must be concise. 0.99. What is the ratio of the Trade (in US$) in Kiribati in 1996 to that in 1998?
Make the answer very short. 1.33. What is the ratio of the Trade (in US$) in Papua New Guinea in 1996 to that in 1998?
Provide a succinct answer. 1.35. What is the ratio of the Trade (in US$) in Least developed countries in 1996 to that in 1999?
Ensure brevity in your answer.  0.93. What is the ratio of the Trade (in US$) in China in 1996 to that in 1999?
Your answer should be compact. 0.84. What is the ratio of the Trade (in US$) in Kiribati in 1996 to that in 1999?
Offer a terse response. 1.24. What is the ratio of the Trade (in US$) of Papua New Guinea in 1996 to that in 1999?
Provide a succinct answer. 1.36. What is the ratio of the Trade (in US$) of Least developed countries in 1996 to that in 2000?
Give a very brief answer. 0.86. What is the ratio of the Trade (in US$) in China in 1996 to that in 2000?
Give a very brief answer. 0.62. What is the ratio of the Trade (in US$) in Kiribati in 1996 to that in 2000?
Offer a very short reply. 0.74. What is the ratio of the Trade (in US$) of Papua New Guinea in 1996 to that in 2000?
Provide a succinct answer. 1.44. What is the ratio of the Trade (in US$) in Least developed countries in 1997 to that in 1998?
Your answer should be very brief. 0.96. What is the ratio of the Trade (in US$) in China in 1997 to that in 1998?
Ensure brevity in your answer.  1.01. What is the ratio of the Trade (in US$) in Kiribati in 1997 to that in 1998?
Your answer should be very brief. 1.23. What is the ratio of the Trade (in US$) of Papua New Guinea in 1997 to that in 1998?
Your answer should be very brief. 1.34. What is the ratio of the Trade (in US$) in Least developed countries in 1997 to that in 1999?
Give a very brief answer. 0.93. What is the ratio of the Trade (in US$) in China in 1997 to that in 1999?
Provide a succinct answer. 0.86. What is the ratio of the Trade (in US$) in Kiribati in 1997 to that in 1999?
Make the answer very short. 1.15. What is the ratio of the Trade (in US$) in Papua New Guinea in 1997 to that in 1999?
Provide a short and direct response. 1.34. What is the ratio of the Trade (in US$) of Least developed countries in 1997 to that in 2000?
Make the answer very short. 0.86. What is the ratio of the Trade (in US$) of China in 1997 to that in 2000?
Offer a terse response. 0.63. What is the ratio of the Trade (in US$) of Kiribati in 1997 to that in 2000?
Give a very brief answer. 0.69. What is the ratio of the Trade (in US$) in Papua New Guinea in 1997 to that in 2000?
Offer a terse response. 1.42. What is the ratio of the Trade (in US$) of Least developed countries in 1998 to that in 1999?
Give a very brief answer. 0.96. What is the ratio of the Trade (in US$) of China in 1998 to that in 1999?
Your answer should be compact. 0.85. What is the ratio of the Trade (in US$) in Kiribati in 1998 to that in 1999?
Offer a terse response. 0.94. What is the ratio of the Trade (in US$) in Least developed countries in 1998 to that in 2000?
Provide a short and direct response. 0.89. What is the ratio of the Trade (in US$) of China in 1998 to that in 2000?
Offer a very short reply. 0.62. What is the ratio of the Trade (in US$) in Kiribati in 1998 to that in 2000?
Give a very brief answer. 0.56. What is the ratio of the Trade (in US$) in Papua New Guinea in 1998 to that in 2000?
Your answer should be very brief. 1.07. What is the ratio of the Trade (in US$) in Least developed countries in 1999 to that in 2000?
Your answer should be very brief. 0.93. What is the ratio of the Trade (in US$) in China in 1999 to that in 2000?
Offer a terse response. 0.74. What is the ratio of the Trade (in US$) of Kiribati in 1999 to that in 2000?
Keep it short and to the point. 0.59. What is the ratio of the Trade (in US$) in Papua New Guinea in 1999 to that in 2000?
Your answer should be very brief. 1.06. What is the difference between the highest and the second highest Trade (in US$) of Least developed countries?
Ensure brevity in your answer.  4.34e+09. What is the difference between the highest and the second highest Trade (in US$) in China?
Offer a terse response. 5.92e+1. What is the difference between the highest and the second highest Trade (in US$) of Kiribati?
Your response must be concise. 1.62e+07. What is the difference between the highest and the second highest Trade (in US$) of Papua New Guinea?
Your answer should be very brief. 2.44e+07. What is the difference between the highest and the lowest Trade (in US$) in Least developed countries?
Your answer should be compact. 2.13e+1. What is the difference between the highest and the lowest Trade (in US$) of China?
Provide a succinct answer. 1.10e+11. What is the difference between the highest and the lowest Trade (in US$) in Kiribati?
Make the answer very short. 2.87e+07. What is the difference between the highest and the lowest Trade (in US$) of Papua New Guinea?
Ensure brevity in your answer.  7.61e+08. 